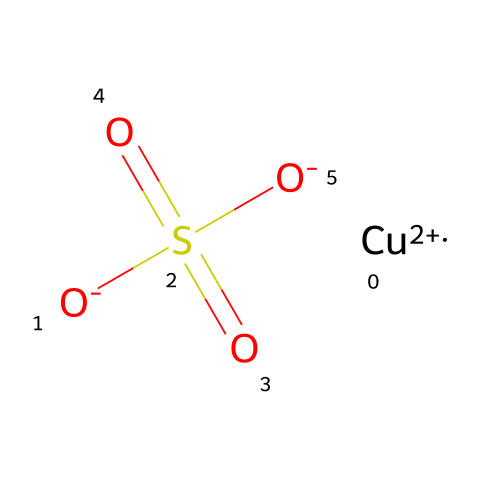How many oxygen atoms are in copper sulfate? The SMILES notation shows three oxygen atoms represented as [O-] and the two double-bonded oxygen atoms in the sulfate group, making a total of five oxygen atoms.
Answer: five What is the central metal ion in this compound? In the provided SMILES representation, the notation [Cu+2] indicates that copper is present as a central metal ion.
Answer: copper How many sulfur atoms are present? The chemical structure contains one sulfur atom indicated by the 'S' in the central part of the molecule, specifically within the sulfate group.
Answer: one What type of bonding is primarily present in copper sulfate? The structure shows ionic bonding due to the presence of a metal (copper) and negatively charged sulfate ions, indicating the predominant type of bonding.
Answer: ionic What is the oxidation state of copper in this compound? The notation [Cu+2] indicates that copper has a +2 oxidation state, which is deduced from the charge assigned to the copper ion.
Answer: +2 Why is copper sulfate effective as a fungicide? The presence of copper ions is known for its antifungal properties, which inhibit fungal growth and reproduction in agricultural applications.
Answer: copper ions Does copper sulfate contain any double bonds? Yes, in the structure, the sulfur atom is doubly bonded to two oxygen atoms, as indicated by the presence of '=O' in the SMILES representation.
Answer: yes 